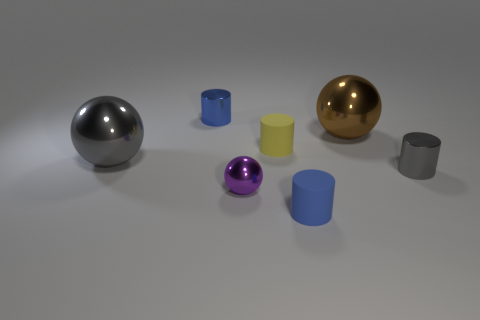What materials do the objects appear to be made of? The spheres have a metallic sheen suggesting they are made of metal, and the cylinders look like they could be made of a matte plastic due to their less reflective surfaces. 